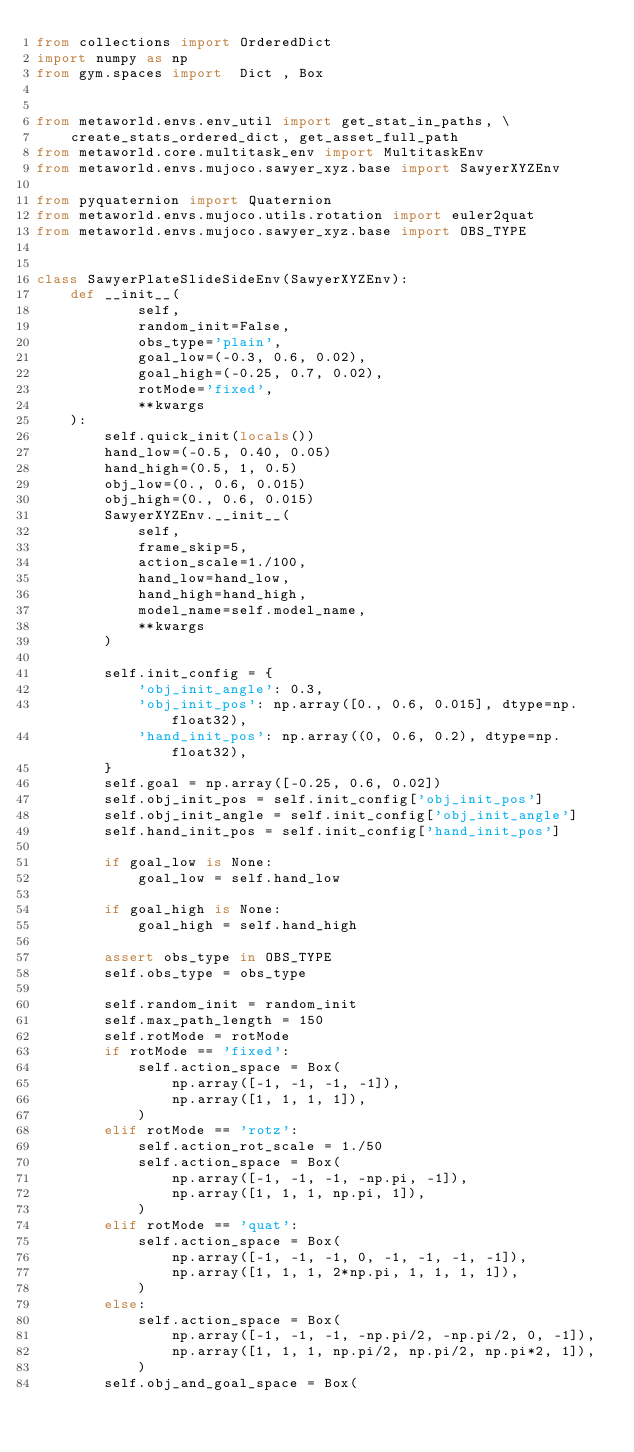Convert code to text. <code><loc_0><loc_0><loc_500><loc_500><_Python_>from collections import OrderedDict
import numpy as np
from gym.spaces import  Dict , Box


from metaworld.envs.env_util import get_stat_in_paths, \
    create_stats_ordered_dict, get_asset_full_path
from metaworld.core.multitask_env import MultitaskEnv
from metaworld.envs.mujoco.sawyer_xyz.base import SawyerXYZEnv

from pyquaternion import Quaternion
from metaworld.envs.mujoco.utils.rotation import euler2quat
from metaworld.envs.mujoco.sawyer_xyz.base import OBS_TYPE


class SawyerPlateSlideSideEnv(SawyerXYZEnv):
    def __init__(
            self,
            random_init=False,
            obs_type='plain',
            goal_low=(-0.3, 0.6, 0.02),
            goal_high=(-0.25, 0.7, 0.02),
            rotMode='fixed',
            **kwargs
    ):
        self.quick_init(locals())
        hand_low=(-0.5, 0.40, 0.05)
        hand_high=(0.5, 1, 0.5)
        obj_low=(0., 0.6, 0.015)
        obj_high=(0., 0.6, 0.015)
        SawyerXYZEnv.__init__(
            self,
            frame_skip=5,
            action_scale=1./100,
            hand_low=hand_low,
            hand_high=hand_high,
            model_name=self.model_name,
            **kwargs
        )

        self.init_config = {
            'obj_init_angle': 0.3,
            'obj_init_pos': np.array([0., 0.6, 0.015], dtype=np.float32),
            'hand_init_pos': np.array((0, 0.6, 0.2), dtype=np.float32),
        }
        self.goal = np.array([-0.25, 0.6, 0.02])
        self.obj_init_pos = self.init_config['obj_init_pos']
        self.obj_init_angle = self.init_config['obj_init_angle']
        self.hand_init_pos = self.init_config['hand_init_pos']

        if goal_low is None:
            goal_low = self.hand_low
        
        if goal_high is None:
            goal_high = self.hand_high

        assert obs_type in OBS_TYPE
        self.obs_type = obs_type

        self.random_init = random_init
        self.max_path_length = 150
        self.rotMode = rotMode
        if rotMode == 'fixed':
            self.action_space = Box(
                np.array([-1, -1, -1, -1]),
                np.array([1, 1, 1, 1]),
            )
        elif rotMode == 'rotz':
            self.action_rot_scale = 1./50
            self.action_space = Box(
                np.array([-1, -1, -1, -np.pi, -1]),
                np.array([1, 1, 1, np.pi, 1]),
            )
        elif rotMode == 'quat':
            self.action_space = Box(
                np.array([-1, -1, -1, 0, -1, -1, -1, -1]),
                np.array([1, 1, 1, 2*np.pi, 1, 1, 1, 1]),
            )
        else:
            self.action_space = Box(
                np.array([-1, -1, -1, -np.pi/2, -np.pi/2, 0, -1]),
                np.array([1, 1, 1, np.pi/2, np.pi/2, np.pi*2, 1]),
            )
        self.obj_and_goal_space = Box(</code> 